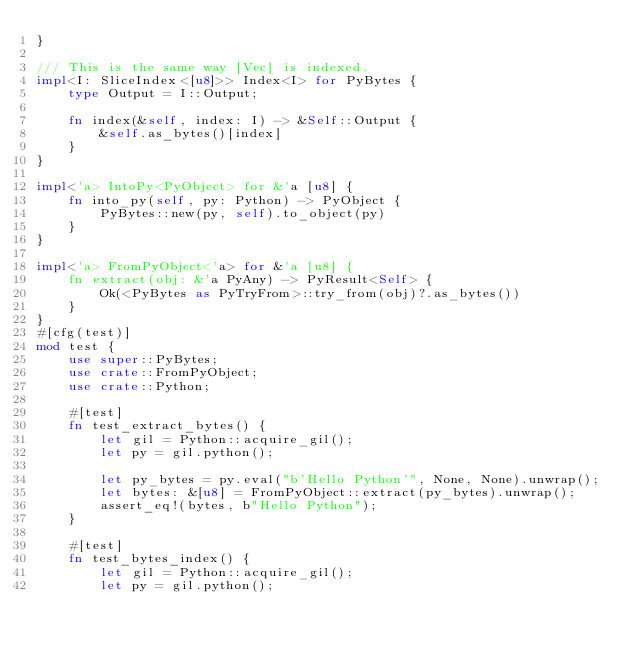<code> <loc_0><loc_0><loc_500><loc_500><_Rust_>}

/// This is the same way [Vec] is indexed.
impl<I: SliceIndex<[u8]>> Index<I> for PyBytes {
    type Output = I::Output;

    fn index(&self, index: I) -> &Self::Output {
        &self.as_bytes()[index]
    }
}

impl<'a> IntoPy<PyObject> for &'a [u8] {
    fn into_py(self, py: Python) -> PyObject {
        PyBytes::new(py, self).to_object(py)
    }
}

impl<'a> FromPyObject<'a> for &'a [u8] {
    fn extract(obj: &'a PyAny) -> PyResult<Self> {
        Ok(<PyBytes as PyTryFrom>::try_from(obj)?.as_bytes())
    }
}
#[cfg(test)]
mod test {
    use super::PyBytes;
    use crate::FromPyObject;
    use crate::Python;

    #[test]
    fn test_extract_bytes() {
        let gil = Python::acquire_gil();
        let py = gil.python();

        let py_bytes = py.eval("b'Hello Python'", None, None).unwrap();
        let bytes: &[u8] = FromPyObject::extract(py_bytes).unwrap();
        assert_eq!(bytes, b"Hello Python");
    }

    #[test]
    fn test_bytes_index() {
        let gil = Python::acquire_gil();
        let py = gil.python();</code> 